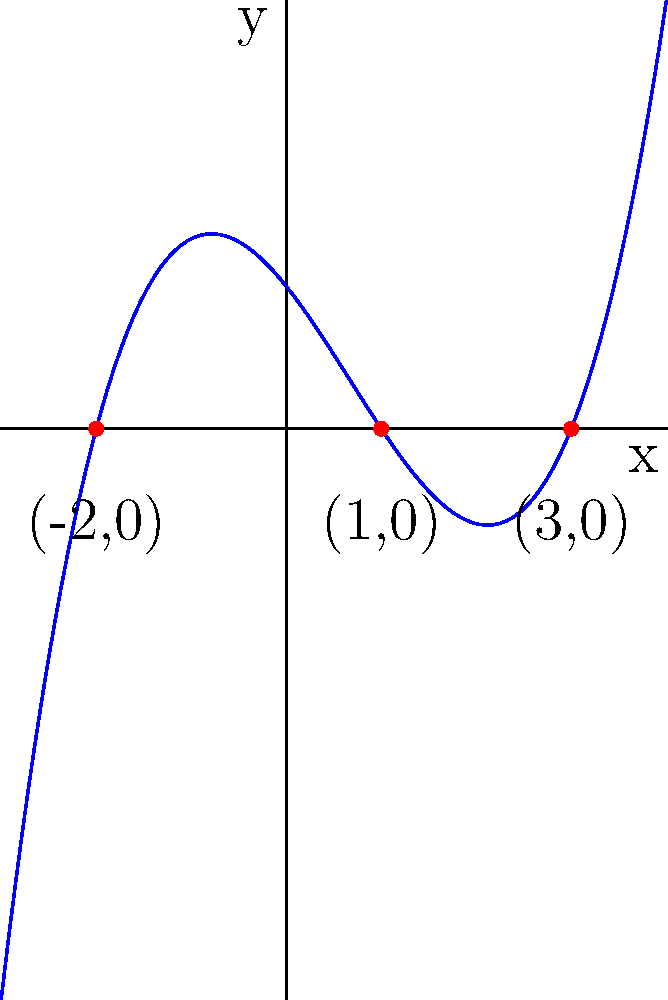As a music graduate from the University of Waterloo, you understand the importance of harmony and composition. Consider the polynomial function graphed above, which resembles a musical waveform. If this function is expressed as $f(x) = ax^3 + bx^2 + cx + d$, what is the value of $a$? Let's approach this step-by-step:

1) The graph shows a cubic function with roots at $x = -2$, $x = 1$, and $x = 3$.

2) The general form of a cubic function with roots $r$, $s$, and $t$ is:
   $f(x) = a(x-r)(x-s)(x-t)$

3) In this case, we have:
   $f(x) = a(x+2)(x-1)(x-3)$

4) Expanding this:
   $f(x) = a(x^2+x-2)(x-3)$
   $f(x) = a(x^3-3x^2+x^2+x-2x+6)$
   $f(x) = ax^3-2ax^2-ax+6a$

5) Comparing this with the standard form $ax^3 + bx^2 + cx + d$, we see that the coefficient of $x^3$ is simply $a$.

6) From the graph, we can see that the function opens upward and its y-intercept is positive. This means $a$ is positive.

7) The y-values seem to increase by about 1 unit for every 2 units on the x-axis in the positive direction. This suggests that $a$ is approximately $1/4$ or $0.25$.

Therefore, the value of $a$ is $0.25$.
Answer: $0.25$ 